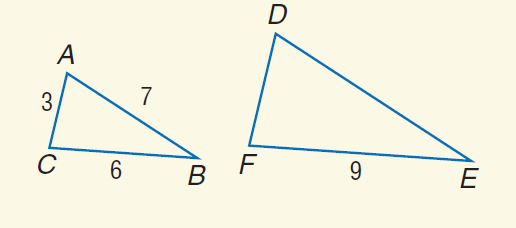Answer the mathemtical geometry problem and directly provide the correct option letter.
Question: Find the perimeter of \triangle D E F if \triangle D E F \sim \triangle A B C.
Choices: A: 15 B: 16 C: 24 D: 30 C 